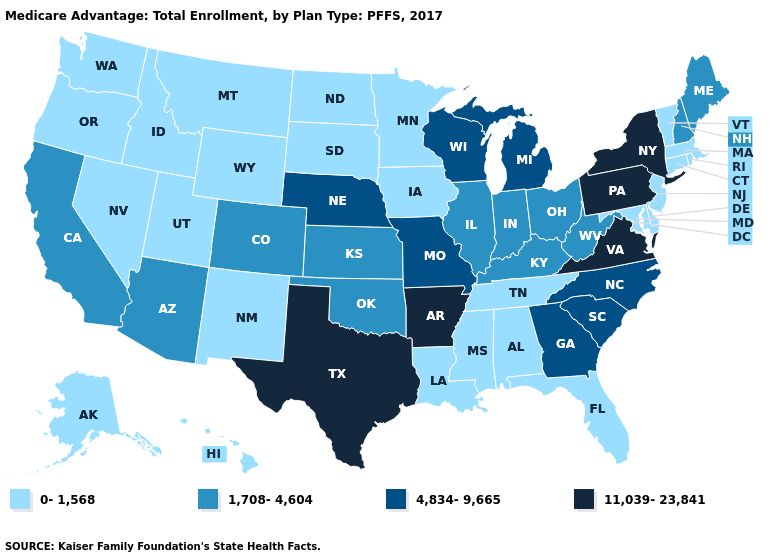Name the states that have a value in the range 4,834-9,665?
Give a very brief answer. Georgia, Michigan, Missouri, North Carolina, Nebraska, South Carolina, Wisconsin. What is the value of Tennessee?
Quick response, please. 0-1,568. What is the value of South Carolina?
Write a very short answer. 4,834-9,665. What is the value of Arkansas?
Write a very short answer. 11,039-23,841. Does Idaho have the lowest value in the USA?
Short answer required. Yes. Which states hav the highest value in the Northeast?
Short answer required. New York, Pennsylvania. Name the states that have a value in the range 11,039-23,841?
Give a very brief answer. Arkansas, New York, Pennsylvania, Texas, Virginia. Name the states that have a value in the range 1,708-4,604?
Write a very short answer. Arizona, California, Colorado, Illinois, Indiana, Kansas, Kentucky, Maine, New Hampshire, Ohio, Oklahoma, West Virginia. Name the states that have a value in the range 4,834-9,665?
Be succinct. Georgia, Michigan, Missouri, North Carolina, Nebraska, South Carolina, Wisconsin. Does Alabama have a lower value than Florida?
Keep it brief. No. What is the lowest value in the USA?
Answer briefly. 0-1,568. Does the first symbol in the legend represent the smallest category?
Quick response, please. Yes. What is the value of Ohio?
Short answer required. 1,708-4,604. Which states have the lowest value in the West?
Keep it brief. Alaska, Hawaii, Idaho, Montana, New Mexico, Nevada, Oregon, Utah, Washington, Wyoming. Name the states that have a value in the range 11,039-23,841?
Give a very brief answer. Arkansas, New York, Pennsylvania, Texas, Virginia. 